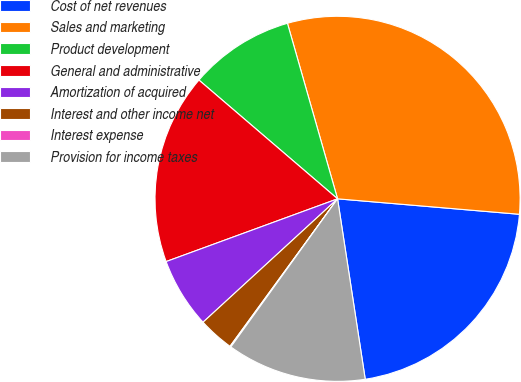Convert chart to OTSL. <chart><loc_0><loc_0><loc_500><loc_500><pie_chart><fcel>Cost of net revenues<fcel>Sales and marketing<fcel>Product development<fcel>General and administrative<fcel>Amortization of acquired<fcel>Interest and other income net<fcel>Interest expense<fcel>Provision for income taxes<nl><fcel>21.23%<fcel>30.78%<fcel>9.3%<fcel>16.86%<fcel>6.23%<fcel>3.16%<fcel>0.09%<fcel>12.36%<nl></chart> 